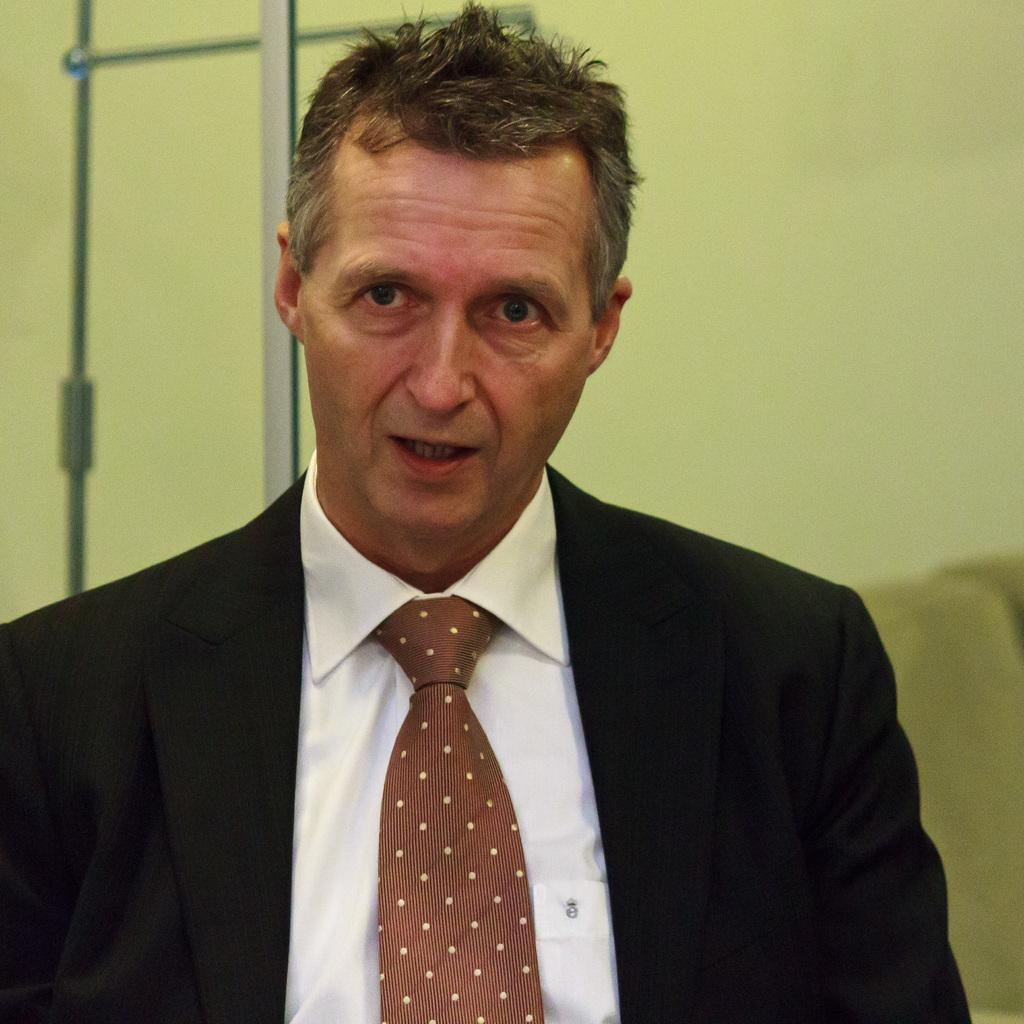Who is present in the image? There is a man in the image. What is the man wearing? The man is wearing a black suit, a white shirt, and a brown tie. What color is the wall in the background of the image? The wall in the background of the image is green. Is there a fire burning in the image? No, there is no fire present in the image. Can you see a blade in the man's hand in the image? No, the man is not holding a blade in the image. 